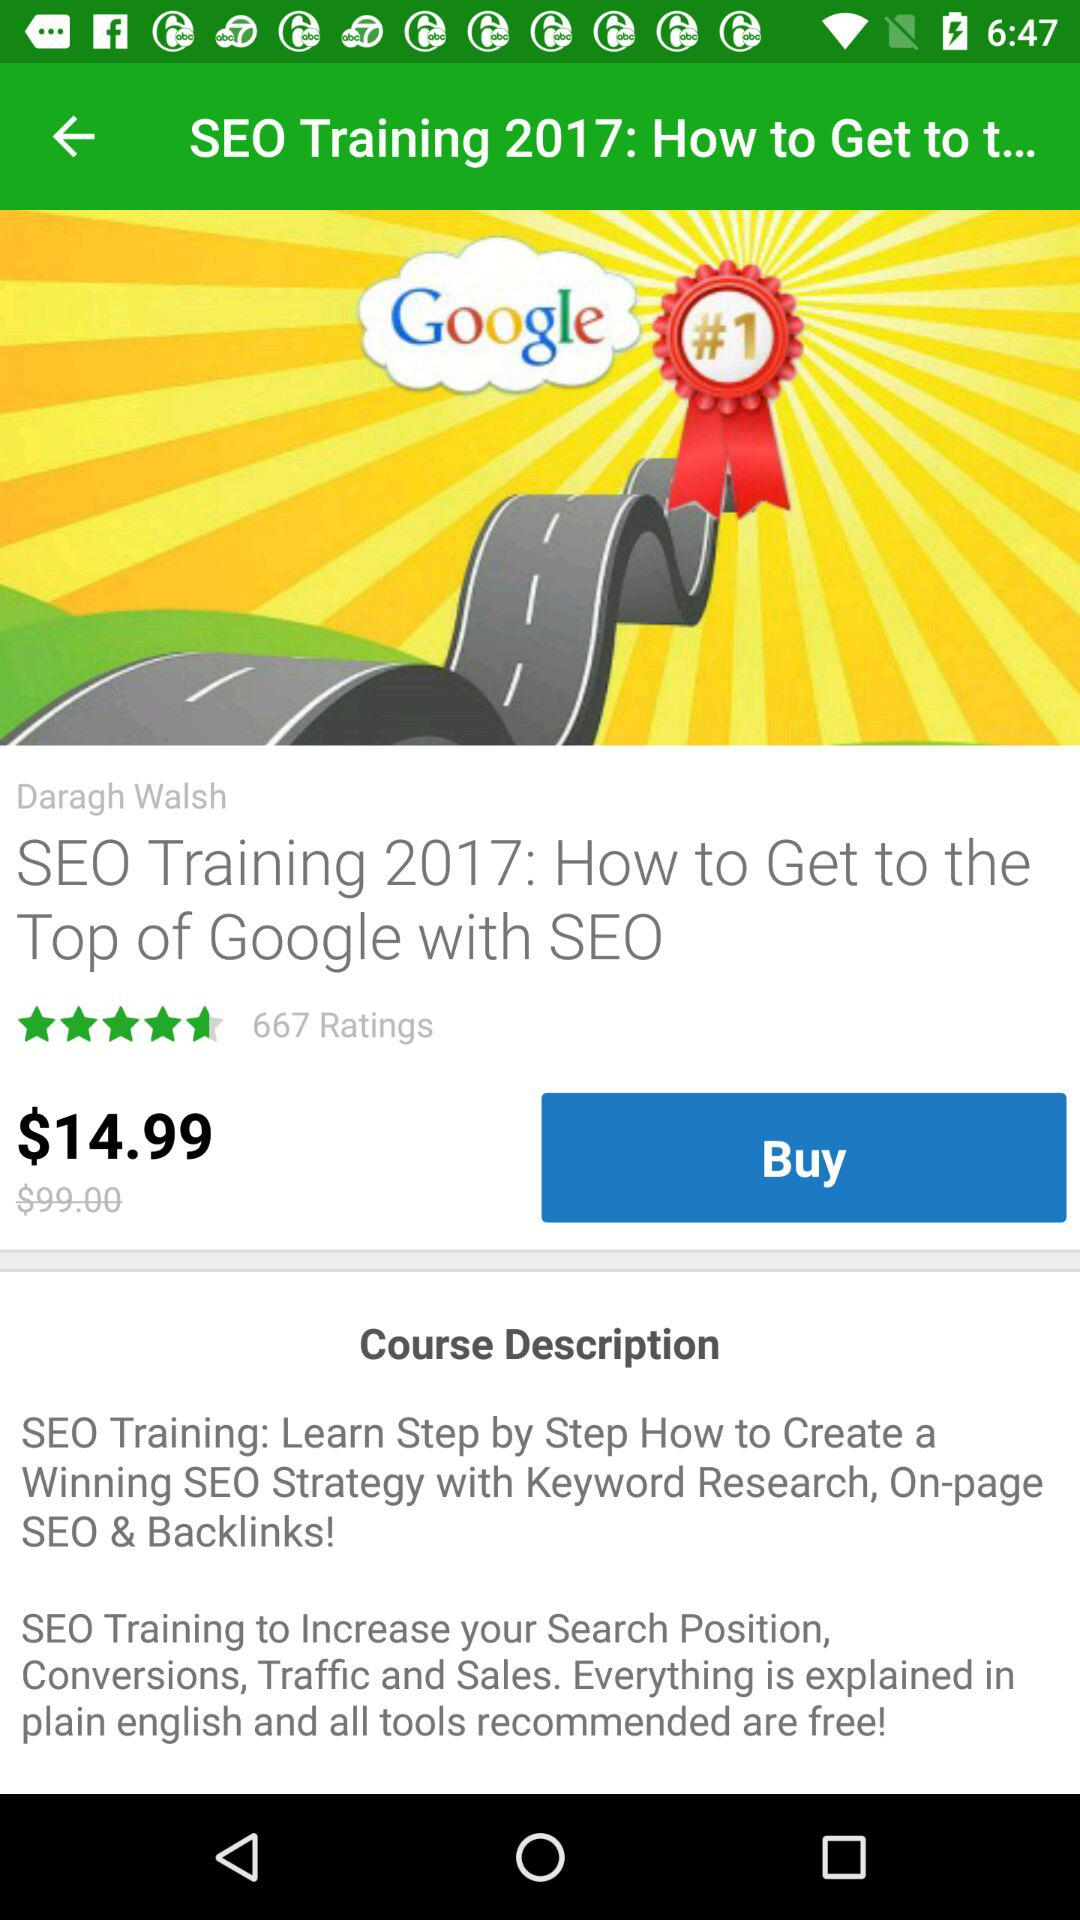How much is the discount on the course?
Answer the question using a single word or phrase. $84.01 